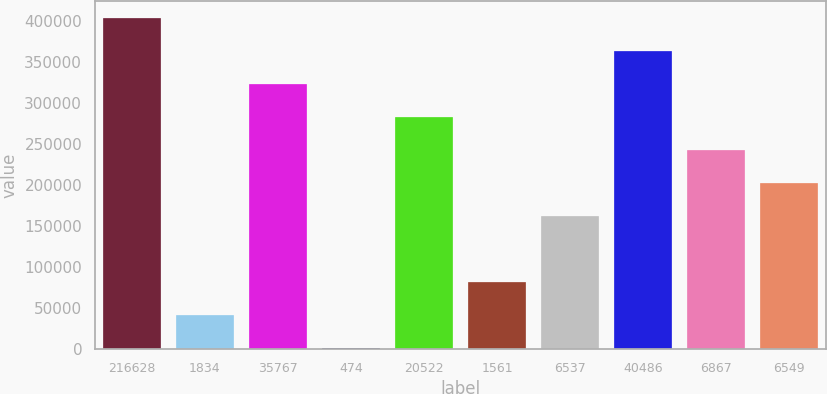<chart> <loc_0><loc_0><loc_500><loc_500><bar_chart><fcel>216628<fcel>1834<fcel>35767<fcel>474<fcel>20522<fcel>1561<fcel>6537<fcel>40486<fcel>6867<fcel>6549<nl><fcel>403233<fcel>40749.9<fcel>322681<fcel>474<fcel>282405<fcel>81025.8<fcel>161578<fcel>362957<fcel>242129<fcel>201854<nl></chart> 